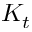Convert formula to latex. <formula><loc_0><loc_0><loc_500><loc_500>K _ { t }</formula> 